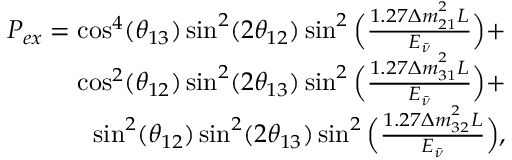<formula> <loc_0><loc_0><loc_500><loc_500>\begin{array} { r } { P _ { e x } = \cos ^ { 4 } ( \theta _ { 1 3 } ) \sin ^ { 2 } ( 2 \theta _ { 1 2 } ) \sin ^ { 2 } \left ( \frac { 1 . 2 7 \Delta m _ { 2 1 } ^ { ^ { 2 } } L } { E _ { \bar { \nu } } } \right ) + } \\ { \cos ^ { 2 } ( \theta _ { 1 2 } ) \sin ^ { 2 } ( 2 \theta _ { 1 3 } ) \sin ^ { 2 } \left ( \frac { 1 . 2 7 \Delta m _ { 3 1 } ^ { ^ { 2 } } L } { E _ { \bar { \nu } } } \right ) + } \\ { \sin ^ { 2 } ( \theta _ { 1 2 } ) \sin ^ { 2 } ( 2 \theta _ { 1 3 } ) \sin ^ { 2 } \left ( \frac { 1 . 2 7 \Delta m _ { 3 2 } ^ { ^ { 2 } } L } { E _ { \bar { \nu } } } \right ) , } \end{array}</formula> 